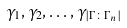<formula> <loc_0><loc_0><loc_500><loc_500>\gamma _ { 1 } , \gamma _ { 2 } , \dots , \gamma _ { \left | \Gamma \colon \Gamma _ { n } \right | }</formula> 